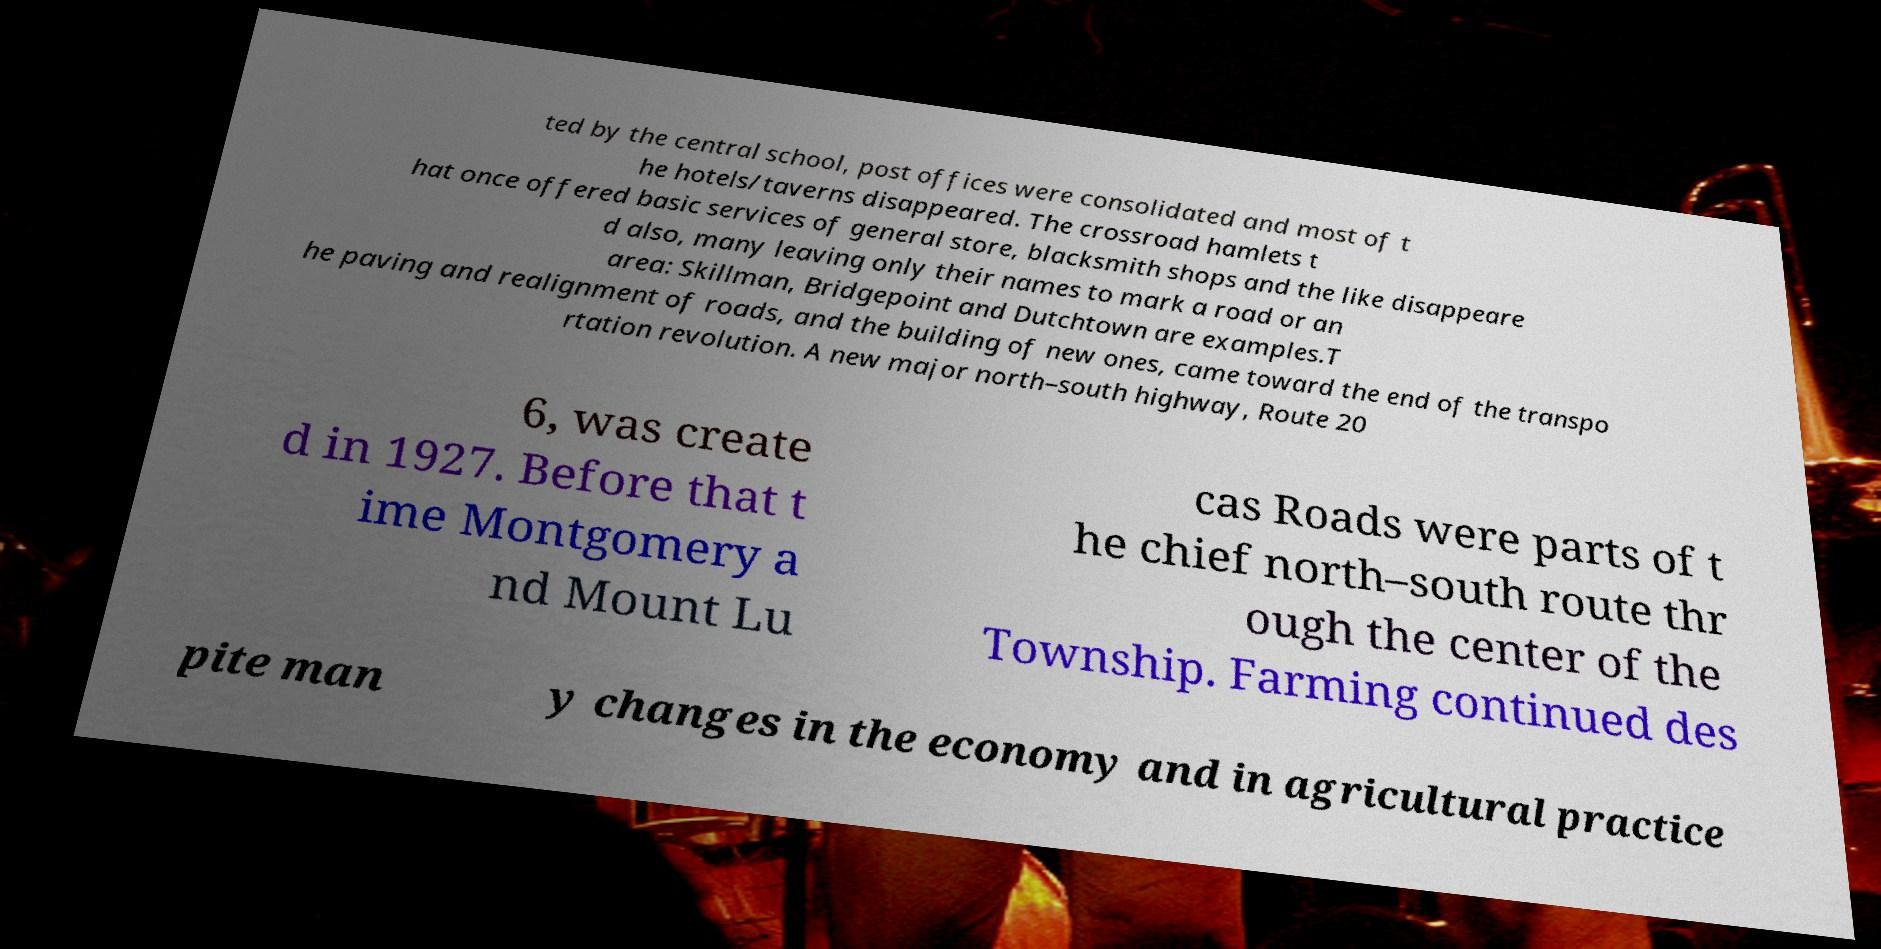Could you extract and type out the text from this image? ted by the central school, post offices were consolidated and most of t he hotels/taverns disappeared. The crossroad hamlets t hat once offered basic services of general store, blacksmith shops and the like disappeare d also, many leaving only their names to mark a road or an area: Skillman, Bridgepoint and Dutchtown are examples.T he paving and realignment of roads, and the building of new ones, came toward the end of the transpo rtation revolution. A new major north–south highway, Route 20 6, was create d in 1927. Before that t ime Montgomery a nd Mount Lu cas Roads were parts of t he chief north–south route thr ough the center of the Township. Farming continued des pite man y changes in the economy and in agricultural practice 